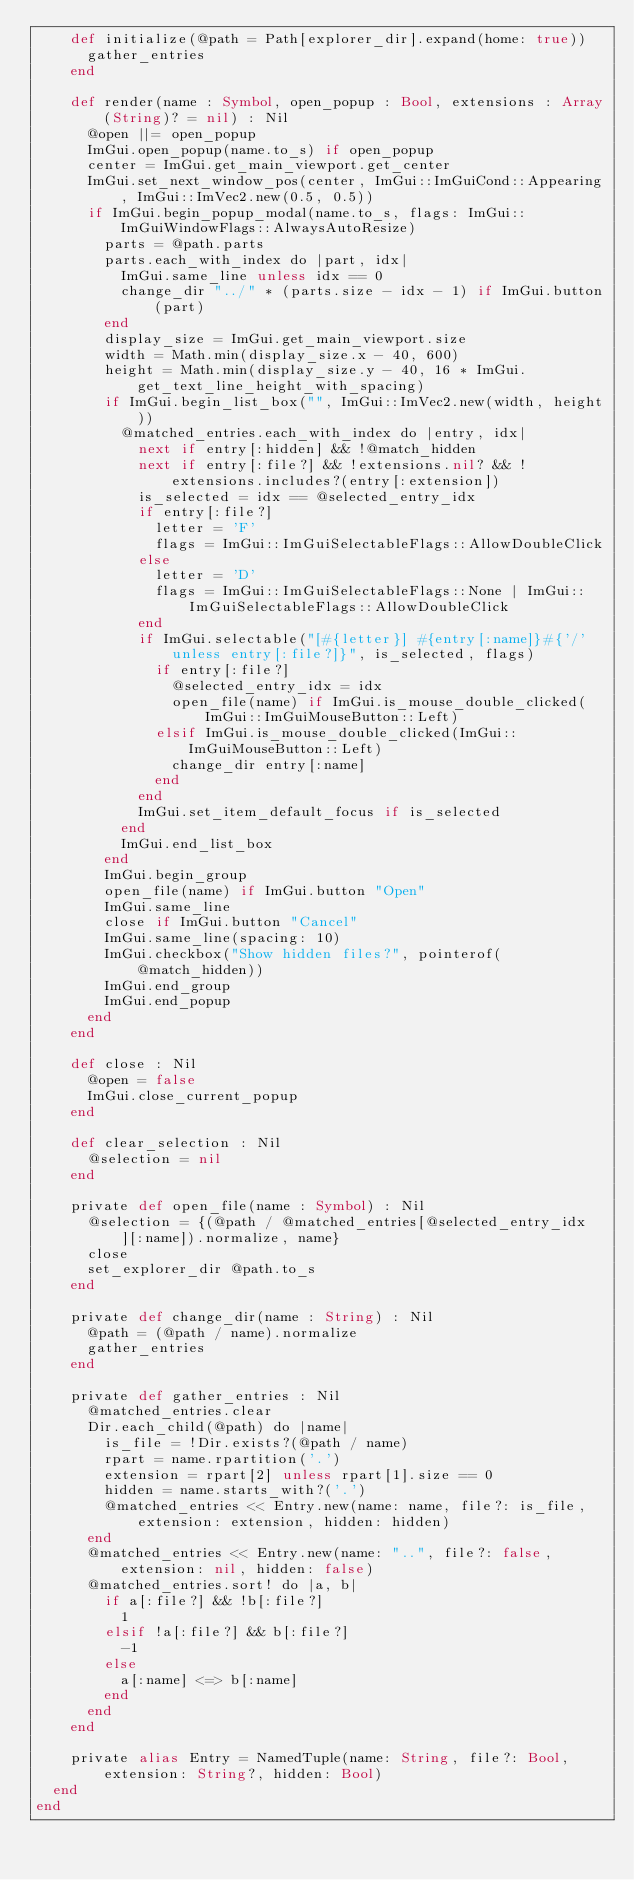Convert code to text. <code><loc_0><loc_0><loc_500><loc_500><_Crystal_>    def initialize(@path = Path[explorer_dir].expand(home: true))
      gather_entries
    end

    def render(name : Symbol, open_popup : Bool, extensions : Array(String)? = nil) : Nil
      @open ||= open_popup
      ImGui.open_popup(name.to_s) if open_popup
      center = ImGui.get_main_viewport.get_center
      ImGui.set_next_window_pos(center, ImGui::ImGuiCond::Appearing, ImGui::ImVec2.new(0.5, 0.5))
      if ImGui.begin_popup_modal(name.to_s, flags: ImGui::ImGuiWindowFlags::AlwaysAutoResize)
        parts = @path.parts
        parts.each_with_index do |part, idx|
          ImGui.same_line unless idx == 0
          change_dir "../" * (parts.size - idx - 1) if ImGui.button(part)
        end
        display_size = ImGui.get_main_viewport.size
        width = Math.min(display_size.x - 40, 600)
        height = Math.min(display_size.y - 40, 16 * ImGui.get_text_line_height_with_spacing)
        if ImGui.begin_list_box("", ImGui::ImVec2.new(width, height))
          @matched_entries.each_with_index do |entry, idx|
            next if entry[:hidden] && !@match_hidden
            next if entry[:file?] && !extensions.nil? && !extensions.includes?(entry[:extension])
            is_selected = idx == @selected_entry_idx
            if entry[:file?]
              letter = 'F'
              flags = ImGui::ImGuiSelectableFlags::AllowDoubleClick
            else
              letter = 'D'
              flags = ImGui::ImGuiSelectableFlags::None | ImGui::ImGuiSelectableFlags::AllowDoubleClick
            end
            if ImGui.selectable("[#{letter}] #{entry[:name]}#{'/' unless entry[:file?]}", is_selected, flags)
              if entry[:file?]
                @selected_entry_idx = idx
                open_file(name) if ImGui.is_mouse_double_clicked(ImGui::ImGuiMouseButton::Left)
              elsif ImGui.is_mouse_double_clicked(ImGui::ImGuiMouseButton::Left)
                change_dir entry[:name]
              end
            end
            ImGui.set_item_default_focus if is_selected
          end
          ImGui.end_list_box
        end
        ImGui.begin_group
        open_file(name) if ImGui.button "Open"
        ImGui.same_line
        close if ImGui.button "Cancel"
        ImGui.same_line(spacing: 10)
        ImGui.checkbox("Show hidden files?", pointerof(@match_hidden))
        ImGui.end_group
        ImGui.end_popup
      end
    end

    def close : Nil
      @open = false
      ImGui.close_current_popup
    end

    def clear_selection : Nil
      @selection = nil
    end

    private def open_file(name : Symbol) : Nil
      @selection = {(@path / @matched_entries[@selected_entry_idx][:name]).normalize, name}
      close
      set_explorer_dir @path.to_s
    end

    private def change_dir(name : String) : Nil
      @path = (@path / name).normalize
      gather_entries
    end

    private def gather_entries : Nil
      @matched_entries.clear
      Dir.each_child(@path) do |name|
        is_file = !Dir.exists?(@path / name)
        rpart = name.rpartition('.')
        extension = rpart[2] unless rpart[1].size == 0
        hidden = name.starts_with?('.')
        @matched_entries << Entry.new(name: name, file?: is_file, extension: extension, hidden: hidden)
      end
      @matched_entries << Entry.new(name: "..", file?: false, extension: nil, hidden: false)
      @matched_entries.sort! do |a, b|
        if a[:file?] && !b[:file?]
          1
        elsif !a[:file?] && b[:file?]
          -1
        else
          a[:name] <=> b[:name]
        end
      end
    end

    private alias Entry = NamedTuple(name: String, file?: Bool, extension: String?, hidden: Bool)
  end
end
</code> 